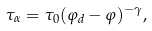<formula> <loc_0><loc_0><loc_500><loc_500>\tau _ { \alpha } = \tau _ { 0 } ( \varphi _ { d } - \varphi ) ^ { - \gamma } ,</formula> 